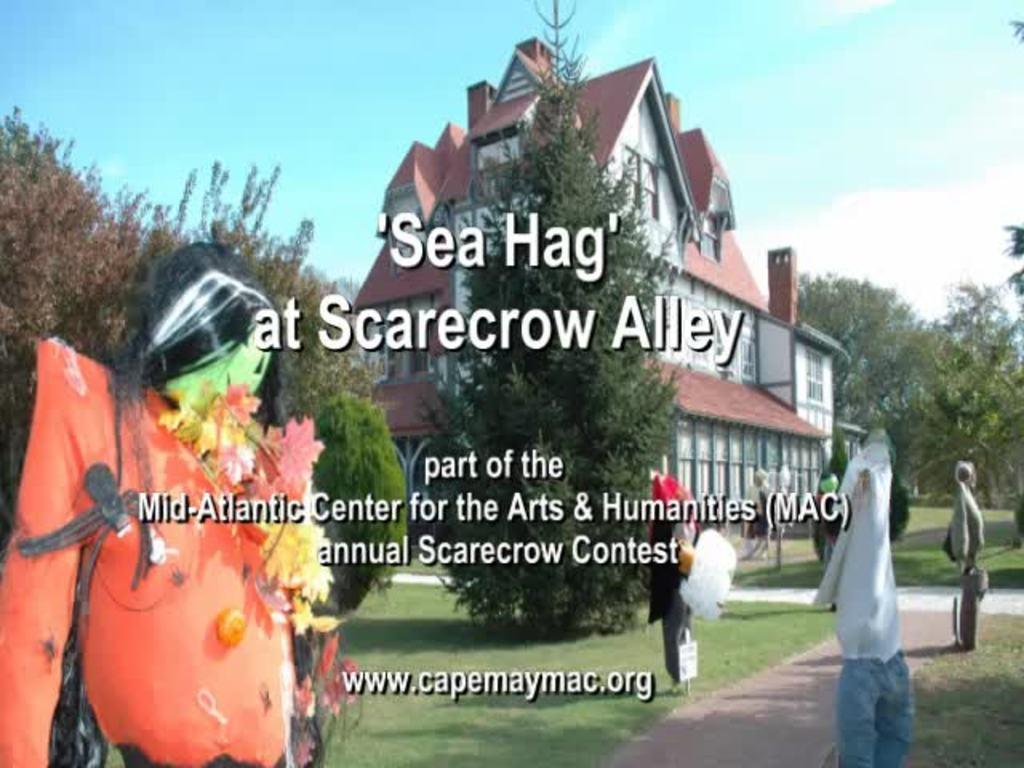What type of objects can be seen in the image? There are dolls in the image. What type of structure is visible in the image? There is a building with windows in the image. What type of natural environment is present in the image? Grass and a group of trees are present in the image. What type of vertical structure can be seen in the image? There is a pole in the image. What part of the sky is visible in the image? The sky is visible in the image. Is there any text present in the image? Yes, there is text present in the image. What type of art can be seen on the dolls' wrists in the image? There is no art visible on the dolls' wrists in the image. What type of skirt is worn by the trees in the image? The trees in the image do not wear skirts; they are natural vegetation. 